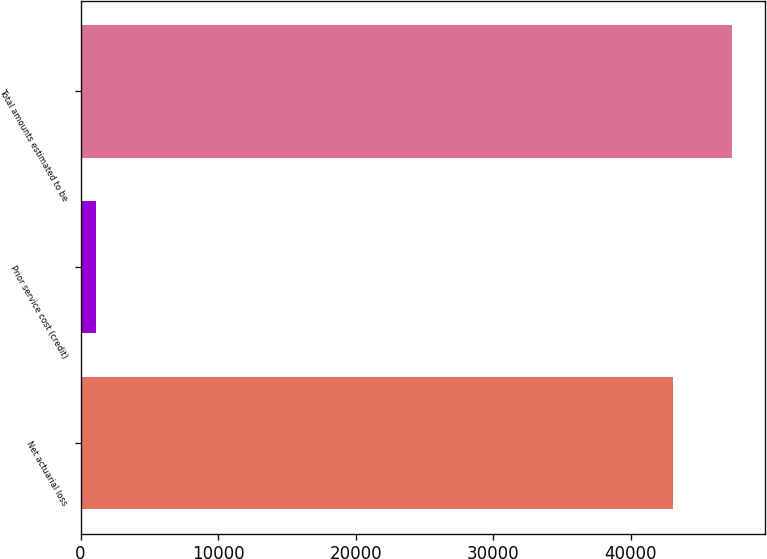Convert chart to OTSL. <chart><loc_0><loc_0><loc_500><loc_500><bar_chart><fcel>Net actuarial loss<fcel>Prior service cost (credit)<fcel>Total amounts estimated to be<nl><fcel>43070<fcel>1143<fcel>47377<nl></chart> 